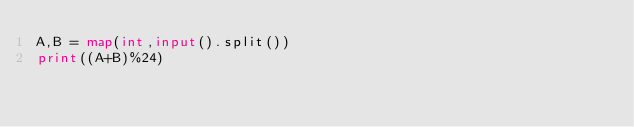Convert code to text. <code><loc_0><loc_0><loc_500><loc_500><_Python_>A,B = map(int,input().split())
print((A+B)%24)</code> 